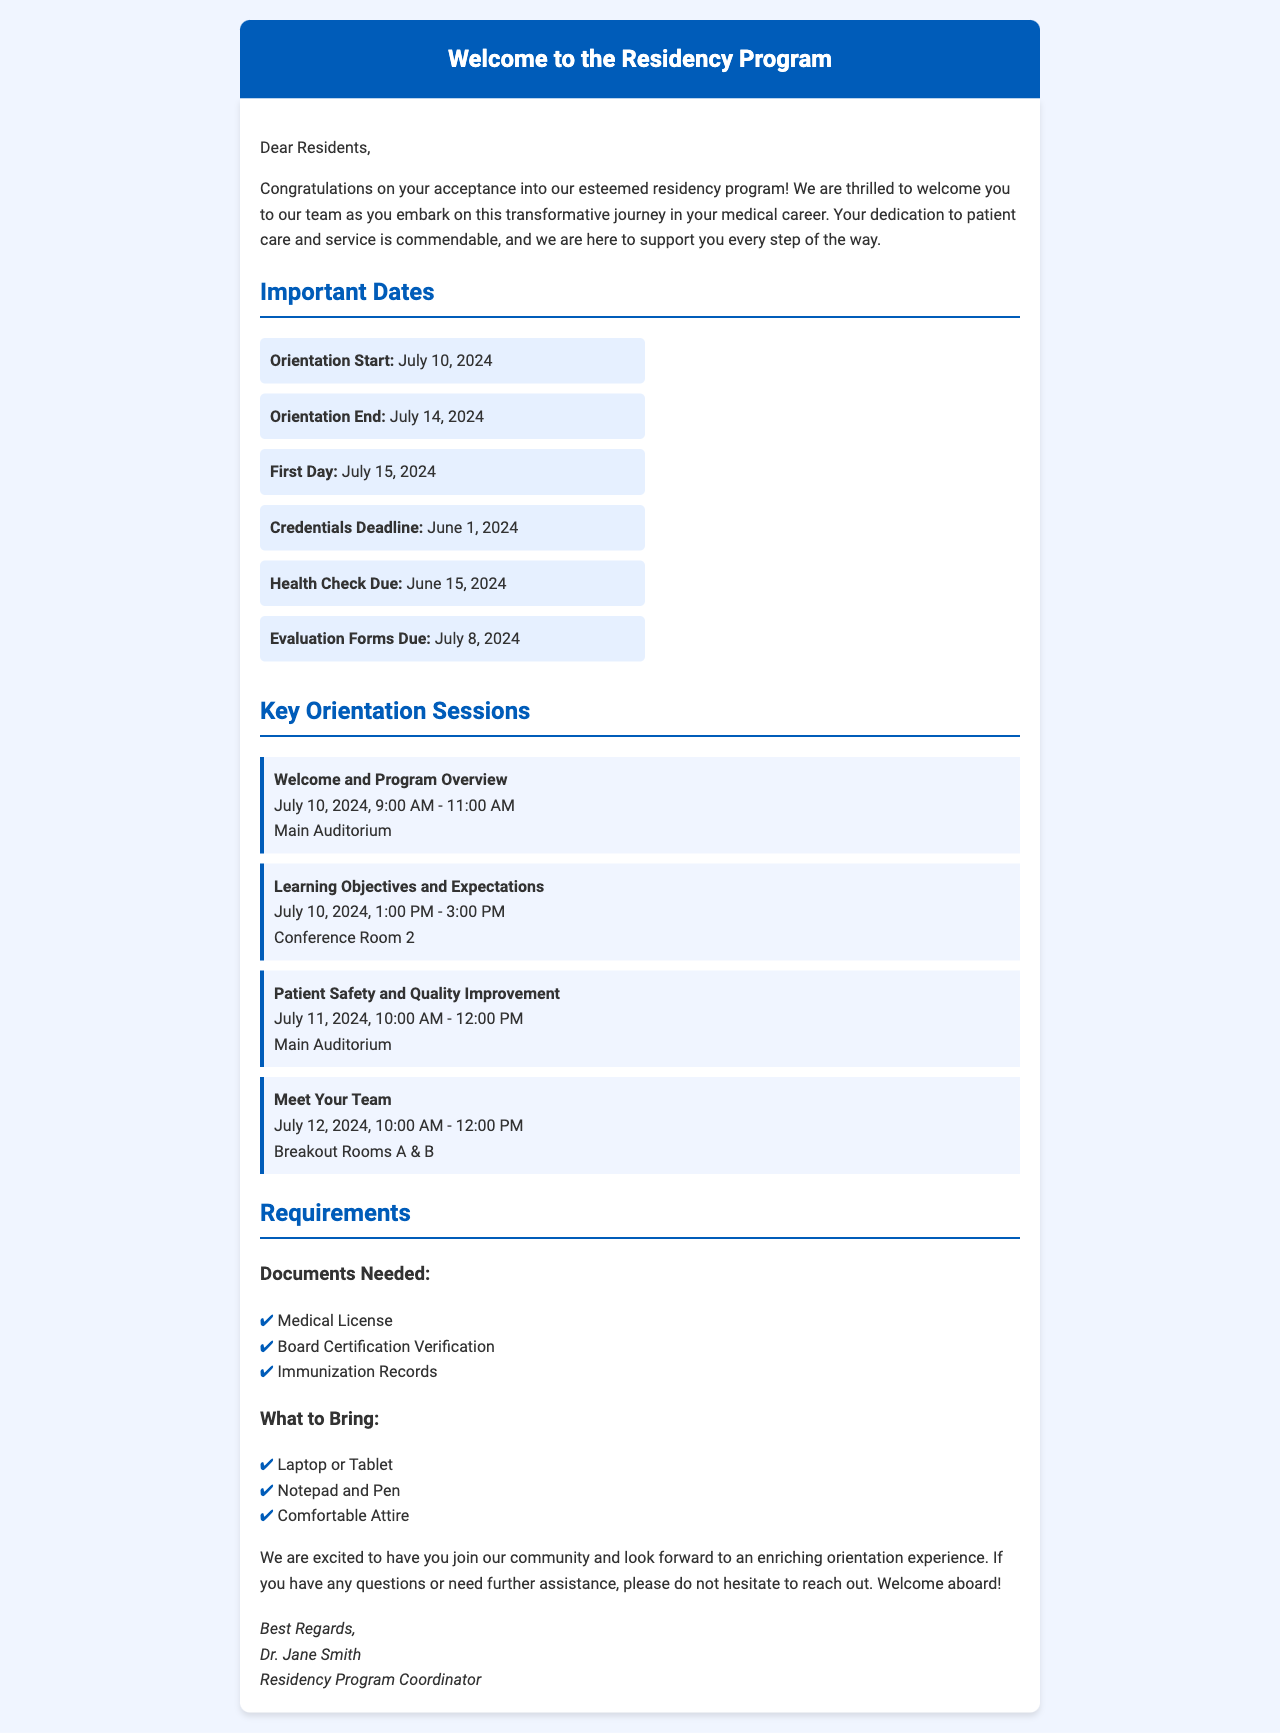What is the orientation start date? The orientation start date is specified in the document as July 10, 2024.
Answer: July 10, 2024 What is the first day of the residency? The first day of the residency is listed in the document as July 15, 2024.
Answer: July 15, 2024 When is the credentials deadline? The credentials deadline can be found in the document under important dates, which is June 1, 2024.
Answer: June 1, 2024 What session is scheduled on July 12, 2024? The document mentions the session "Meet Your Team" is on that date.
Answer: Meet Your Team What documents are needed for the residency? The needed documents are outlined in the document's requirements section, including Medical License, Board Certification Verification, and Immunization Records.
Answer: Medical License, Board Certification Verification, Immunization Records What should I bring to the orientation? The document provides a list of items to bring, such as a Laptop or Tablet, Notepad and Pen, and Comfortable Attire.
Answer: Laptop or Tablet, Notepad and Pen, Comfortable Attire Who is the residency program coordinator? The document identifies Dr. Jane Smith as the residency program coordinator.
Answer: Dr. Jane Smith How long is the orientation? The orientation duration can be derived from the start and end dates mentioned in the document, spanning from July 10 to July 14, 2024, which is 5 days.
Answer: 5 days 